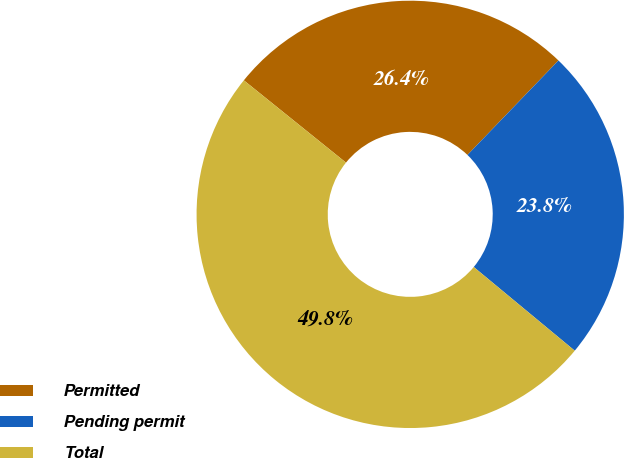Convert chart to OTSL. <chart><loc_0><loc_0><loc_500><loc_500><pie_chart><fcel>Permitted<fcel>Pending permit<fcel>Total<nl><fcel>26.41%<fcel>23.81%<fcel>49.78%<nl></chart> 